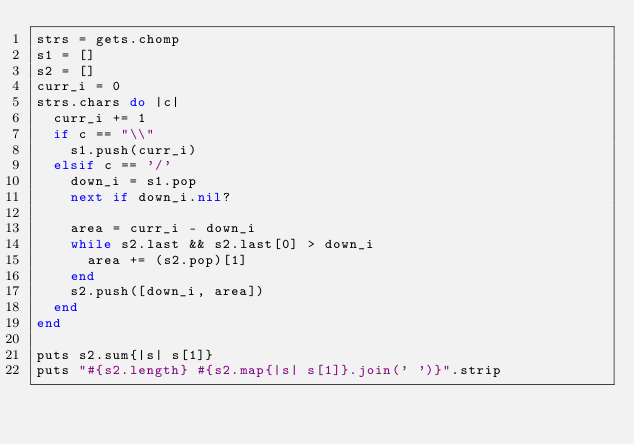Convert code to text. <code><loc_0><loc_0><loc_500><loc_500><_Ruby_>strs = gets.chomp
s1 = []
s2 = []
curr_i = 0
strs.chars do |c|
  curr_i += 1
  if c == "\\"
    s1.push(curr_i)
  elsif c == '/'
    down_i = s1.pop
    next if down_i.nil?

    area = curr_i - down_i
    while s2.last && s2.last[0] > down_i
      area += (s2.pop)[1]
    end
    s2.push([down_i, area])
  end
end

puts s2.sum{|s| s[1]}
puts "#{s2.length} #{s2.map{|s| s[1]}.join(' ')}".strip
</code> 